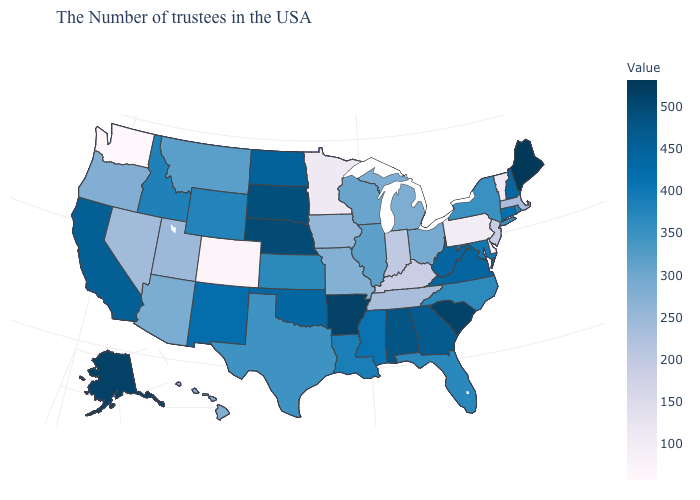Which states hav the highest value in the MidWest?
Give a very brief answer. Nebraska. Which states have the lowest value in the USA?
Short answer required. Washington. Among the states that border Maryland , which have the highest value?
Keep it brief. Virginia. 